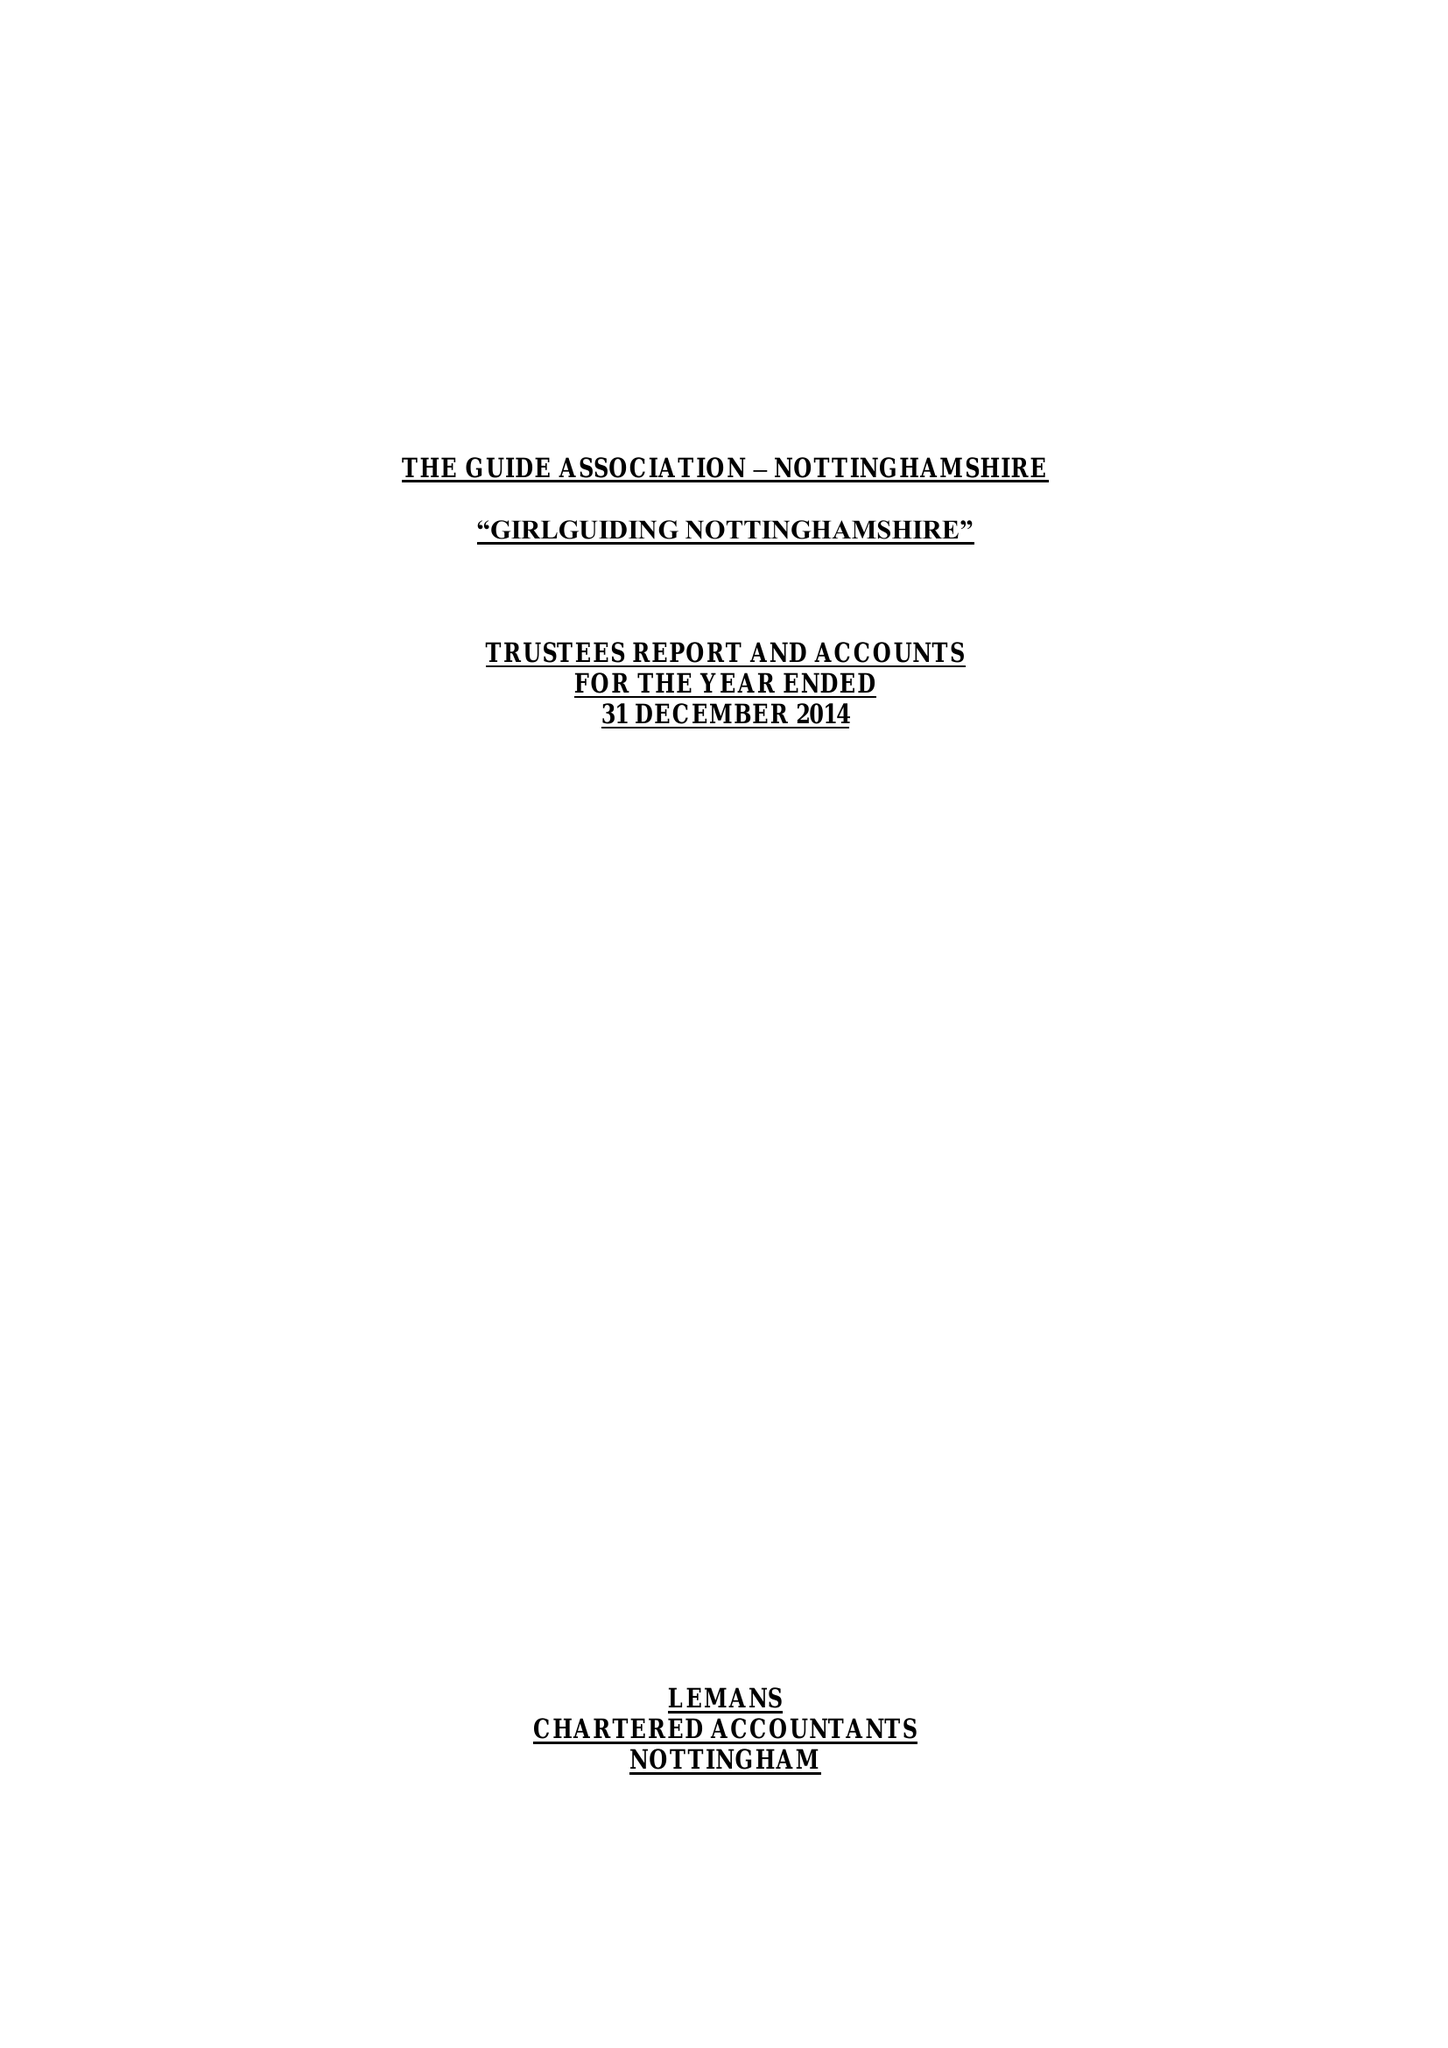What is the value for the address__street_line?
Answer the question using a single word or phrase. 16-18 BURTON ROAD 